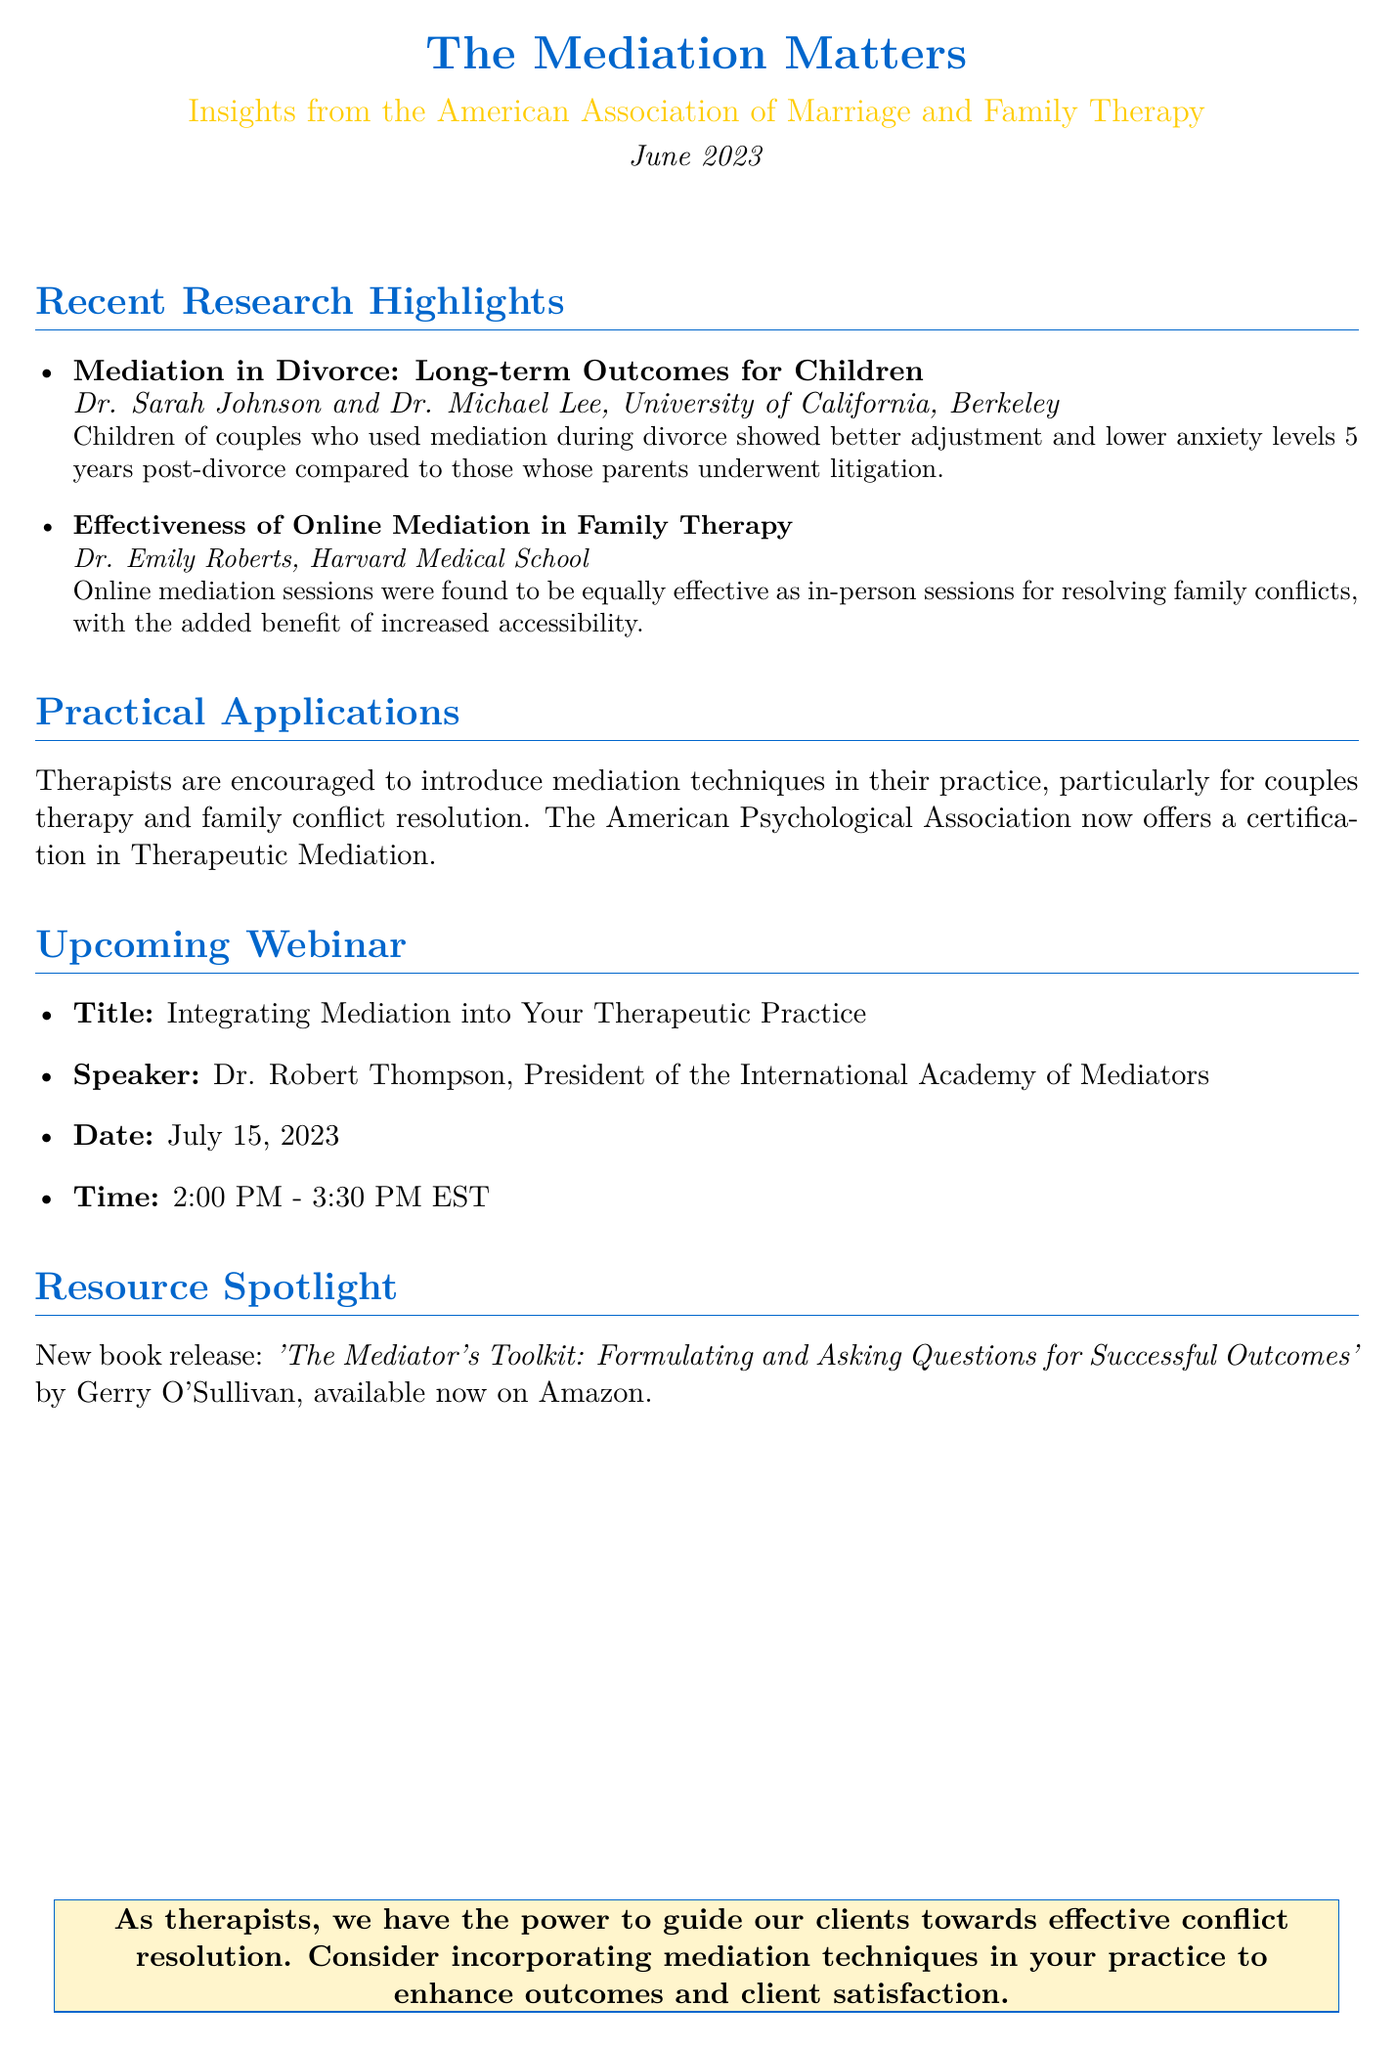what is the title of the newsletter? The title of the newsletter is mentioned at the beginning of the document.
Answer: The Mediation Matters who are the authors of the study on mediation in divorce? The authors of the study are listed under the research highlight section.
Answer: Dr. Sarah Johnson and Dr. Michael Lee what is the date of the upcoming webinar? The date of the upcoming webinar is specified in the document.
Answer: July 15, 2023 who is the speaker for the webinar? The speaker is introduced in the upcoming webinar section of the document.
Answer: Dr. Robert Thompson what is the main benefit of online mediation mentioned in the newsletter? The main benefit is explained in the effectiveness section of the document.
Answer: Increased accessibility what is the key finding of the study on mediation in divorce? The key finding is summarized under the research highlight section.
Answer: Better adjustment and lower anxiety levels what new certification is offered by the American Psychological Association? The certification is mentioned in the practical applications section.
Answer: Therapeutic Mediation what is the title of the newly released book highlighted in the newsletter? The title of the book is mentioned in the resource spotlight section.
Answer: The Mediator's Toolkit: Formulating and Asking Questions for Successful Outcomes 